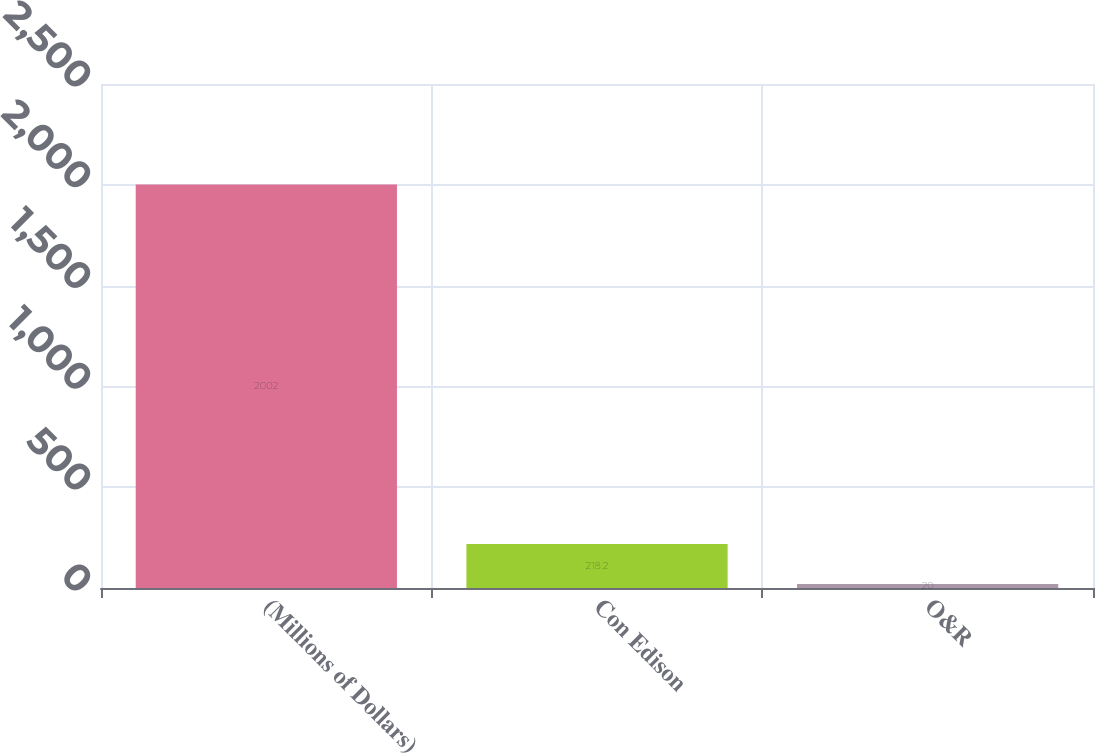Convert chart to OTSL. <chart><loc_0><loc_0><loc_500><loc_500><bar_chart><fcel>(Millions of Dollars)<fcel>Con Edison<fcel>O&R<nl><fcel>2002<fcel>218.2<fcel>20<nl></chart> 